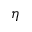<formula> <loc_0><loc_0><loc_500><loc_500>\eta</formula> 